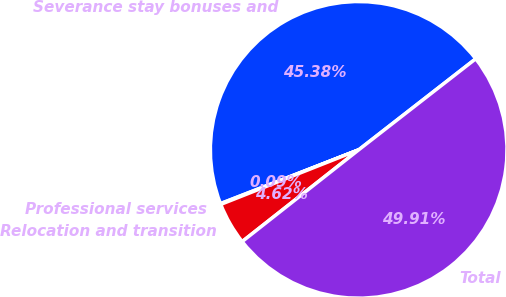<chart> <loc_0><loc_0><loc_500><loc_500><pie_chart><fcel>Severance stay bonuses and<fcel>Professional services<fcel>Relocation and transition<fcel>Total<nl><fcel>45.38%<fcel>0.09%<fcel>4.62%<fcel>49.91%<nl></chart> 